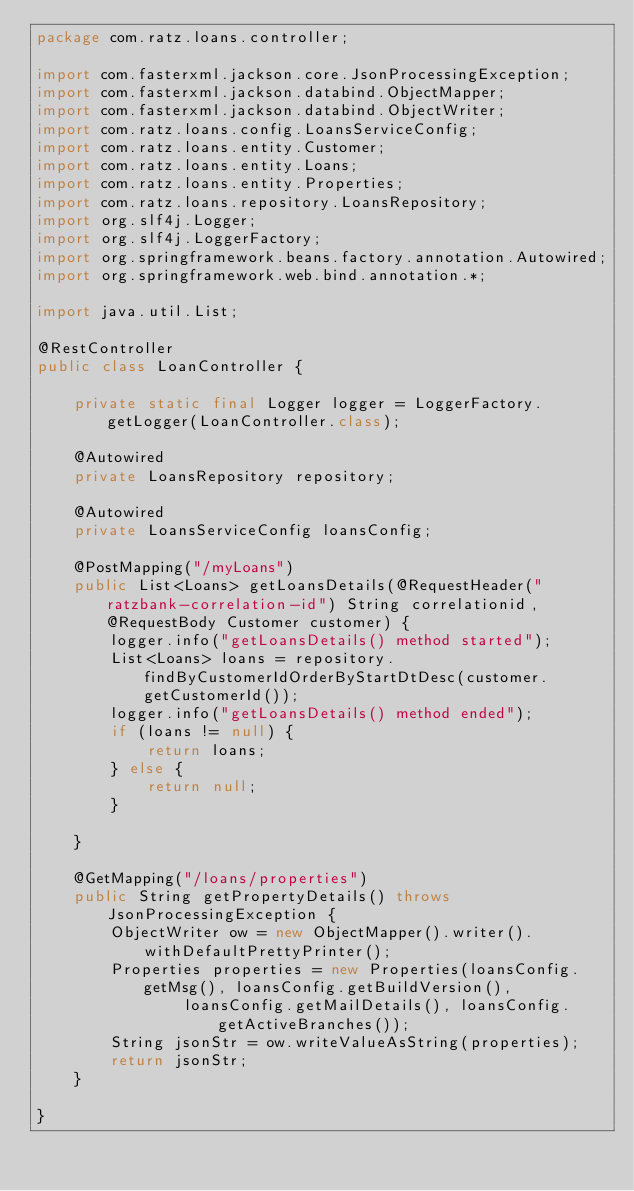Convert code to text. <code><loc_0><loc_0><loc_500><loc_500><_Java_>package com.ratz.loans.controller;

import com.fasterxml.jackson.core.JsonProcessingException;
import com.fasterxml.jackson.databind.ObjectMapper;
import com.fasterxml.jackson.databind.ObjectWriter;
import com.ratz.loans.config.LoansServiceConfig;
import com.ratz.loans.entity.Customer;
import com.ratz.loans.entity.Loans;
import com.ratz.loans.entity.Properties;
import com.ratz.loans.repository.LoansRepository;
import org.slf4j.Logger;
import org.slf4j.LoggerFactory;
import org.springframework.beans.factory.annotation.Autowired;
import org.springframework.web.bind.annotation.*;

import java.util.List;

@RestController
public class LoanController {

    private static final Logger logger = LoggerFactory.getLogger(LoanController.class);

    @Autowired
    private LoansRepository repository;

    @Autowired
    private LoansServiceConfig loansConfig;

    @PostMapping("/myLoans")
    public List<Loans> getLoansDetails(@RequestHeader("ratzbank-correlation-id") String correlationid, @RequestBody Customer customer) {
        logger.info("getLoansDetails() method started");
        List<Loans> loans = repository.findByCustomerIdOrderByStartDtDesc(customer.getCustomerId());
        logger.info("getLoansDetails() method ended");
        if (loans != null) {
            return loans;
        } else {
            return null;
        }

    }

    @GetMapping("/loans/properties")
    public String getPropertyDetails() throws JsonProcessingException {
        ObjectWriter ow = new ObjectMapper().writer().withDefaultPrettyPrinter();
        Properties properties = new Properties(loansConfig.getMsg(), loansConfig.getBuildVersion(),
                loansConfig.getMailDetails(), loansConfig.getActiveBranches());
        String jsonStr = ow.writeValueAsString(properties);
        return jsonStr;
    }

}
</code> 